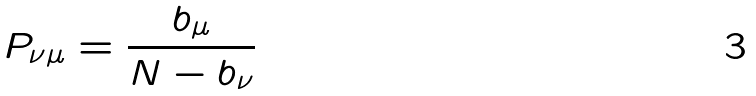Convert formula to latex. <formula><loc_0><loc_0><loc_500><loc_500>P _ { \nu \mu } = \frac { b _ { \mu } } { N - b _ { \nu } }</formula> 